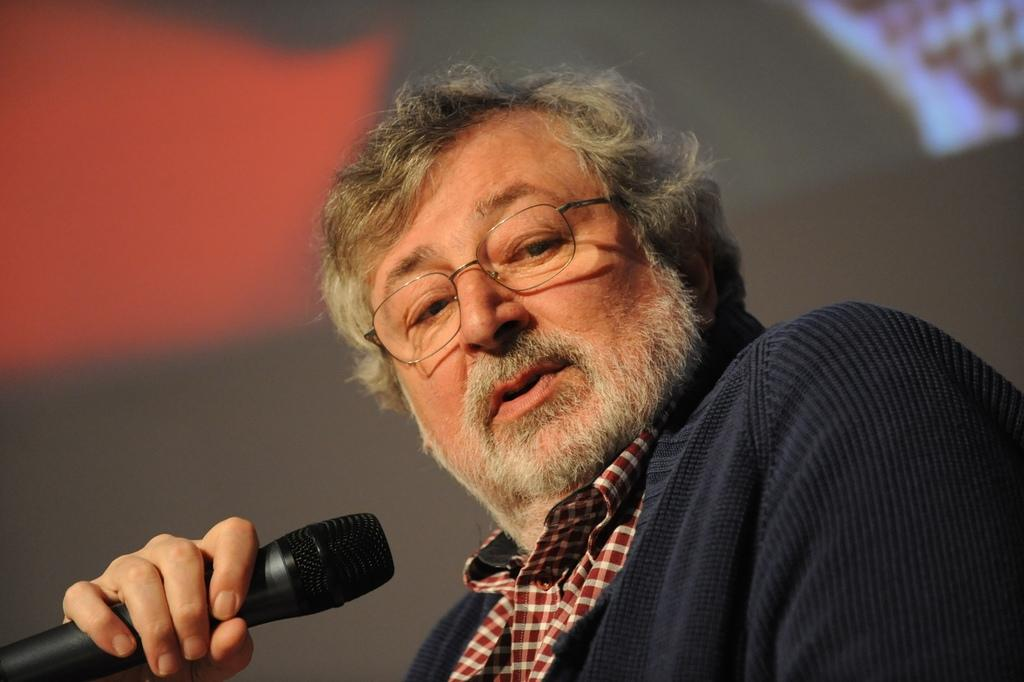Who is the main subject in the image? There is a man in the image. What is the man wearing? The man is wearing spectacles. What is the man holding in his hand? The man is holding a mic in his hand. How would you describe the background of the image? The background of the image is blurry. Can you see any jelly on the man's clothing in the image? There is no jelly present on the man's clothing in the image. What type of vehicle is parked near the man in the image? There is no vehicle present in the image. 